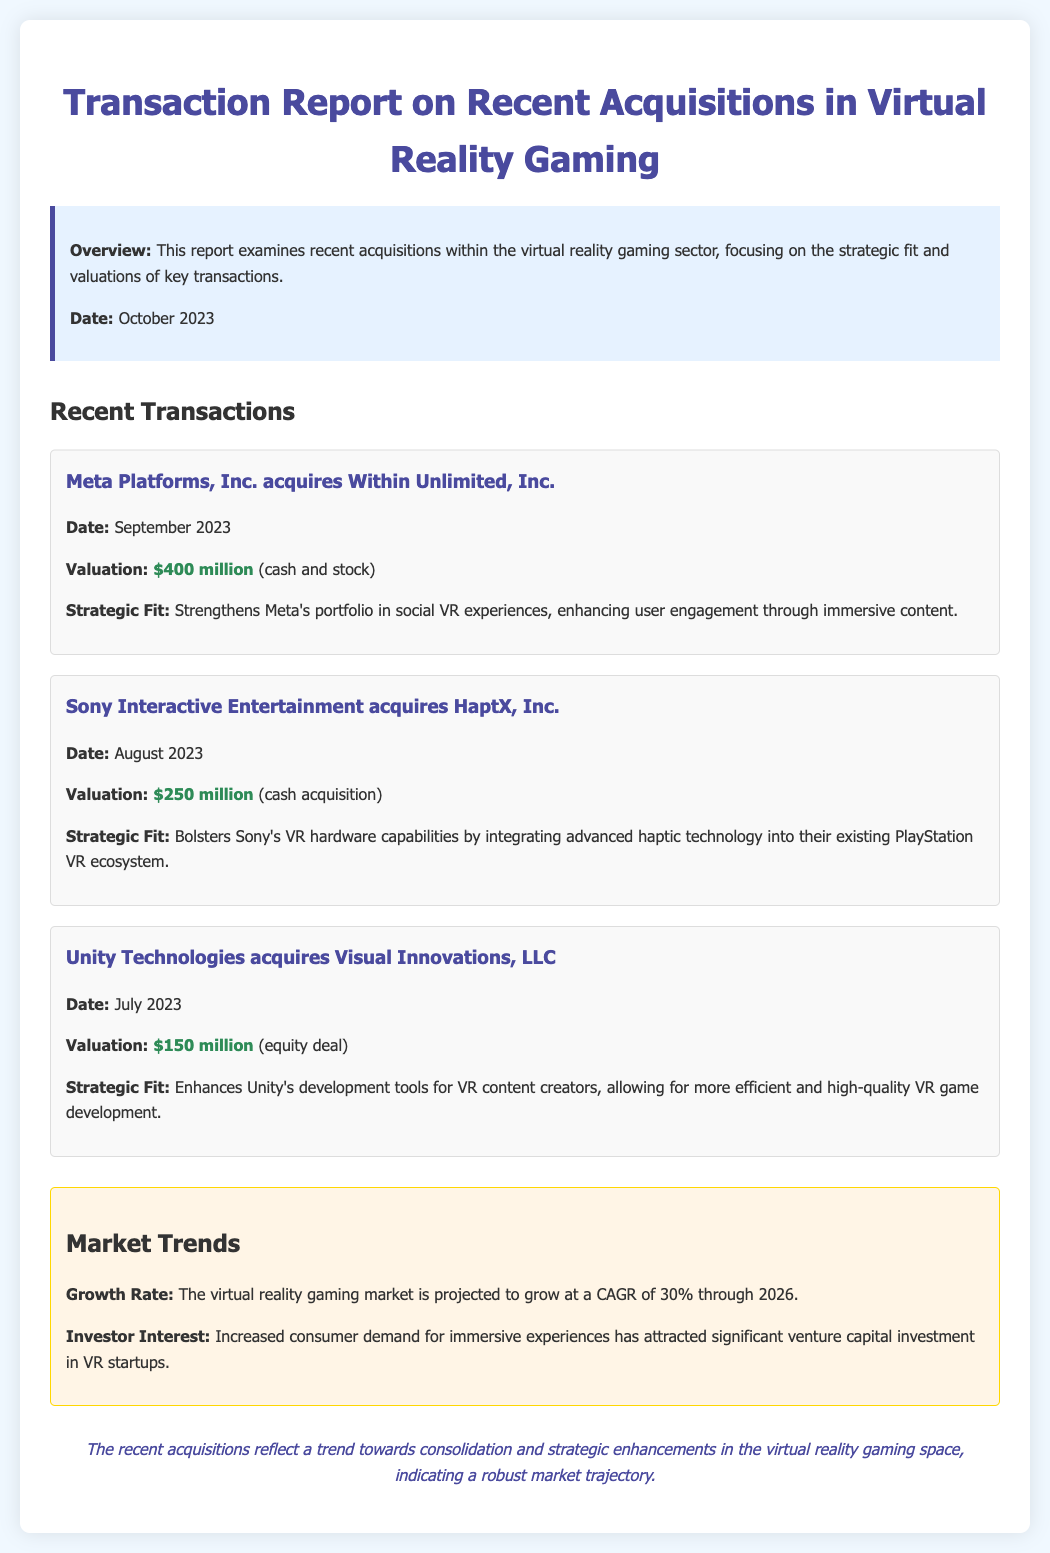What is the date of the latest acquisition reported? The date of the latest acquisition reported in the document is September 2023.
Answer: September 2023 How much was Meta Platforms, Inc. valued in the acquisition? The valuation for Meta Platforms, Inc. in the acquisition of Within Unlimited, Inc. is specifically stated as $400 million.
Answer: $400 million What technology does Sony aim to integrate through its acquisition? The acquisition of HaptX, Inc. by Sony aims to integrate advanced haptic technology into their existing PlayStation VR ecosystem.
Answer: Haptic technology What is the total valuation of the acquisitions listed? The total valuation includes three transactions: $400 million, $250 million, and $150 million, totaling $800 million.
Answer: $800 million What is the projected growth rate for the virtual reality gaming market? The document mentions that the virtual reality gaming market is projected to grow at a CAGR of 30% through 2026.
Answer: 30% What strategic enhancement does Unity Technologies seek through its acquisition? Unity Technologies seeks to enhance its development tools for VR content creators through the acquisition of Visual Innovations, LLC.
Answer: Development tools Which company acquired Visual Innovations, LLC? The document indicates that Unity Technologies is the company that acquired Visual Innovations, LLC.
Answer: Unity Technologies What was the date of the acquisition involving Sony Interactive Entertainment? The acquisition date involving Sony Interactive Entertainment is listed as August 2023.
Answer: August 2023 What is the overall conclusion drawn in the report? The report concludes that recent acquisitions reflect consolidation and strategic enhancements in the virtual reality gaming space.
Answer: Consolidation and strategic enhancements 